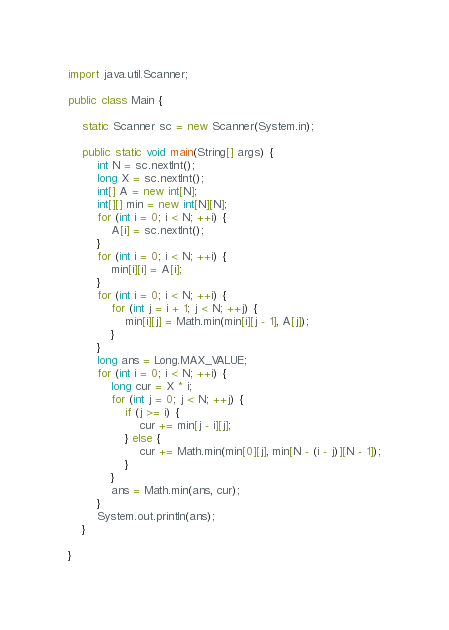Convert code to text. <code><loc_0><loc_0><loc_500><loc_500><_Java_>import java.util.Scanner;

public class Main {

	static Scanner sc = new Scanner(System.in);

	public static void main(String[] args) {
		int N = sc.nextInt();
		long X = sc.nextInt();
		int[] A = new int[N];
		int[][] min = new int[N][N];
		for (int i = 0; i < N; ++i) {
			A[i] = sc.nextInt();
		}
		for (int i = 0; i < N; ++i) {
			min[i][i] = A[i];
		}
		for (int i = 0; i < N; ++i) {
			for (int j = i + 1; j < N; ++j) {
				min[i][j] = Math.min(min[i][j - 1], A[j]);
			}
		}
		long ans = Long.MAX_VALUE;
		for (int i = 0; i < N; ++i) {
			long cur = X * i;
			for (int j = 0; j < N; ++j) {
				if (j >= i) {
					cur += min[j - i][j];
				} else {
					cur += Math.min(min[0][j], min[N - (i - j)][N - 1]);
				}
			}
			ans = Math.min(ans, cur);
		}
		System.out.println(ans);
	}

}
</code> 